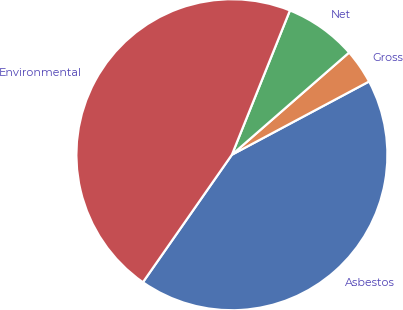Convert chart to OTSL. <chart><loc_0><loc_0><loc_500><loc_500><pie_chart><fcel>Asbestos<fcel>Gross<fcel>Net<fcel>Environmental<nl><fcel>42.5%<fcel>3.61%<fcel>7.5%<fcel>46.39%<nl></chart> 